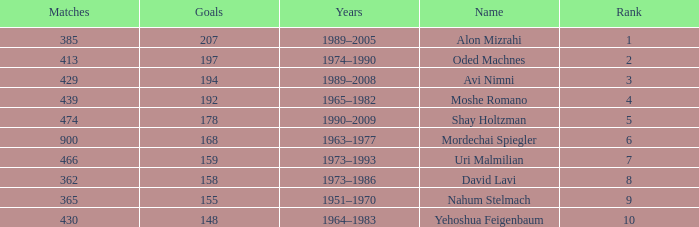What is the Rank of the player with 362 Matches? 8.0. 